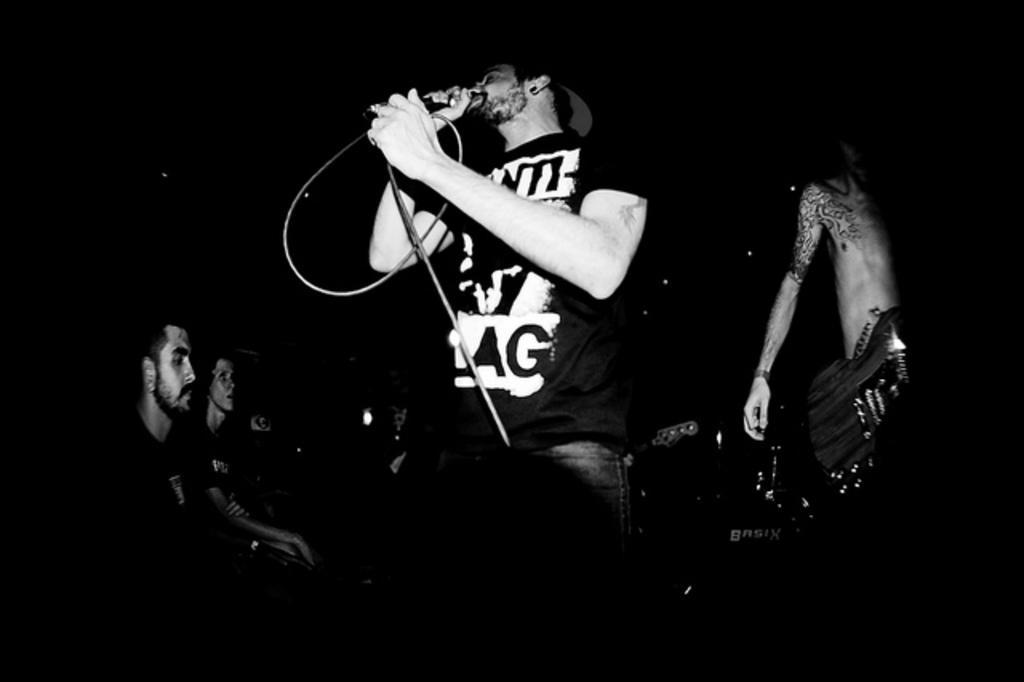Can you describe this image briefly? This picture shows a man standing and singing with the help of a microphone and we see few people seated and a man standing on his side 